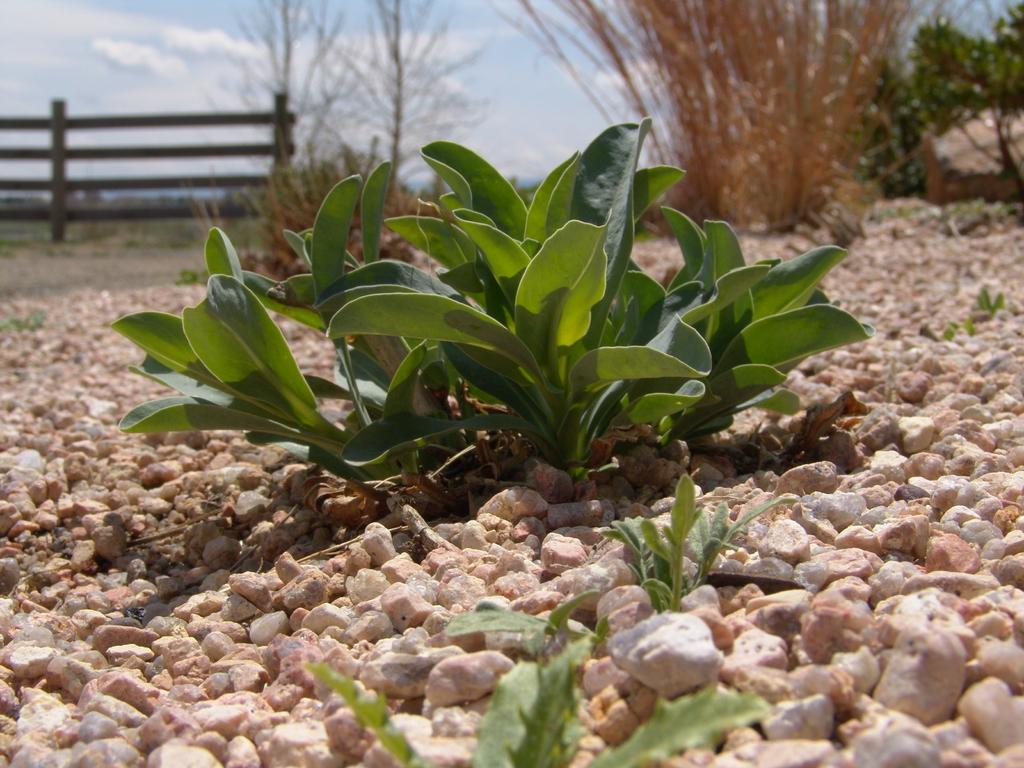What type of vegetation can be seen in the image? There are plants and trees in the image. What is on the ground in the image? There are stones on the ground in the image. What type of barrier is present in the image? There is a wooden fence in the image. How would you describe the sky in the image? The sky is blue and cloudy in the image. Can you hear a stranger making noise in the image? There is no sound or stranger present in the image, so it is not possible to answer that question. 